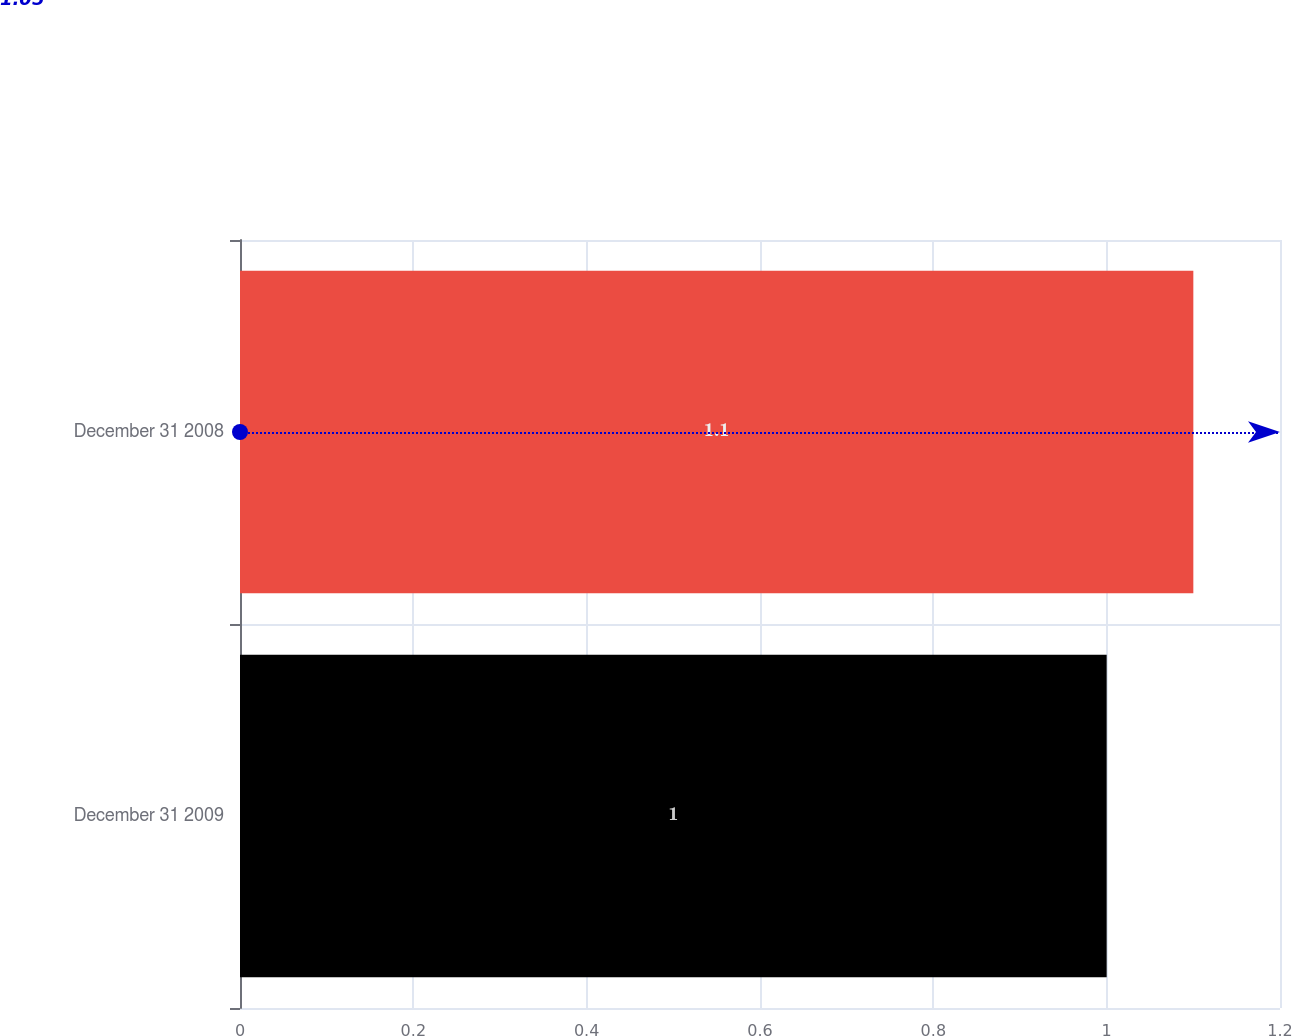Convert chart. <chart><loc_0><loc_0><loc_500><loc_500><bar_chart><fcel>December 31 2009<fcel>December 31 2008<nl><fcel>1<fcel>1.1<nl></chart> 